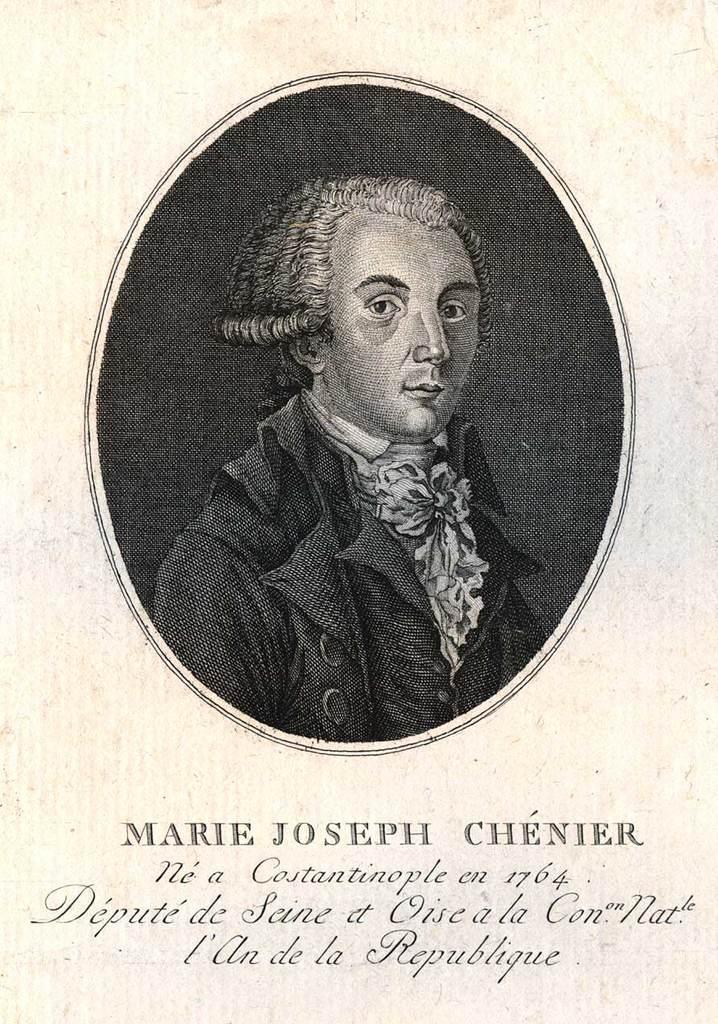Please provide a concise description of this image. This looks like a paper. I can see the black and white picture of a person on the paper. These are the letters. 